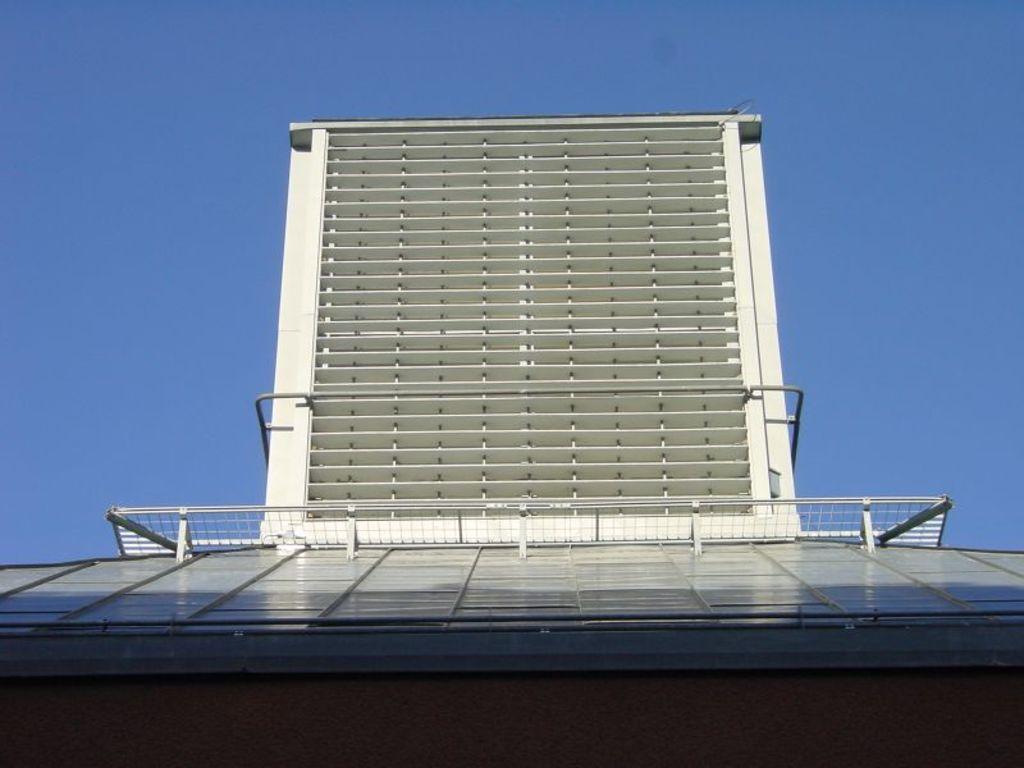Could you give a brief overview of what you see in this image? In the foreground of the picture there is a building and railing. Sky is clear and it is sunny. 